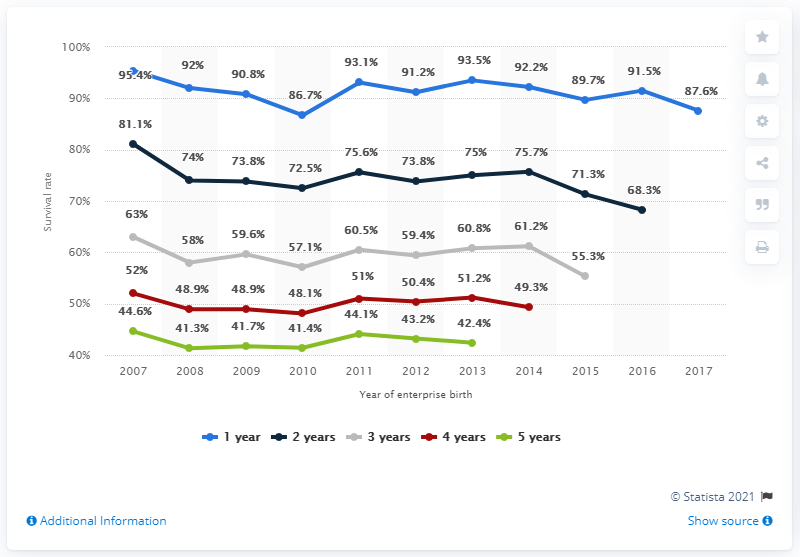Indicate a few pertinent items in this graphic. In 2010, the survival rate of new enterprises that had survived one year was 86.7%. The product of the highest and lowest value of enterprises that survived five years is 1841.98. The survival rate for enterprises founded in 2013 was 93.5%. 